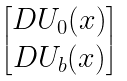<formula> <loc_0><loc_0><loc_500><loc_500>\begin{bmatrix} D U _ { 0 } ( x ) \\ D U _ { b } ( x ) \end{bmatrix}</formula> 